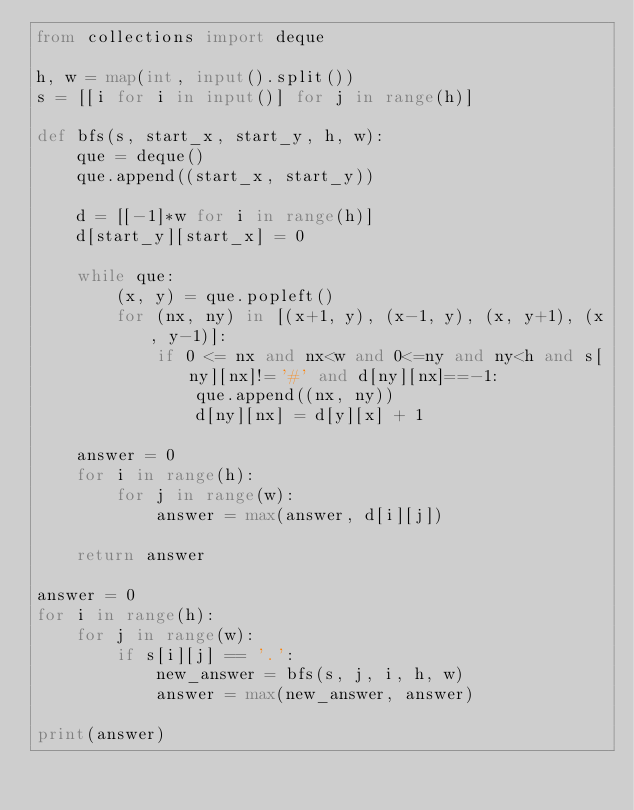<code> <loc_0><loc_0><loc_500><loc_500><_Python_>from collections import deque

h, w = map(int, input().split())
s = [[i for i in input()] for j in range(h)]

def bfs(s, start_x, start_y, h, w):
    que = deque()
    que.append((start_x, start_y))
    
    d = [[-1]*w for i in range(h)]
    d[start_y][start_x] = 0
    
    while que:
        (x, y) = que.popleft()
        for (nx, ny) in [(x+1, y), (x-1, y), (x, y+1), (x, y-1)]:
            if 0 <= nx and nx<w and 0<=ny and ny<h and s[ny][nx]!='#' and d[ny][nx]==-1:
                que.append((nx, ny))
                d[ny][nx] = d[y][x] + 1
                
    answer = 0    
    for i in range(h):
        for j in range(w):
            answer = max(answer, d[i][j])
                        
    return answer

answer = 0
for i in range(h):
    for j in range(w):
        if s[i][j] == '.':
            new_answer = bfs(s, j, i, h, w)
            answer = max(new_answer, answer) 
            
print(answer)</code> 